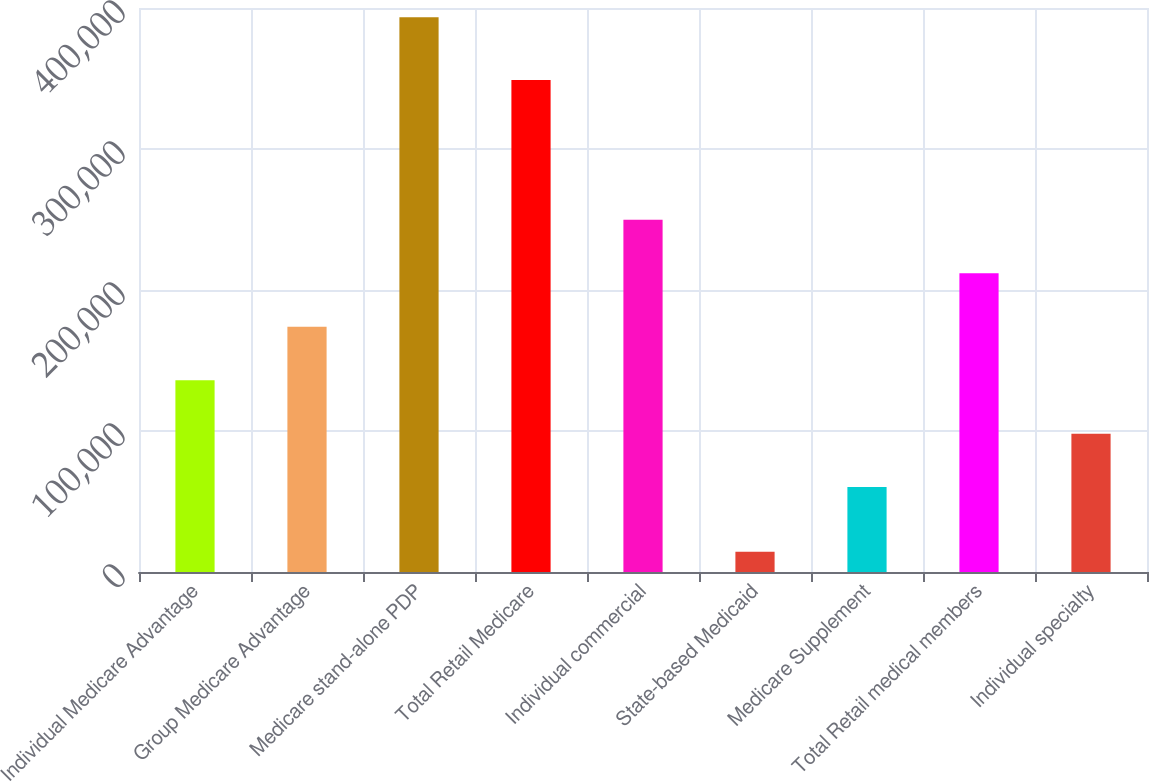<chart> <loc_0><loc_0><loc_500><loc_500><bar_chart><fcel>Individual Medicare Advantage<fcel>Group Medicare Advantage<fcel>Medicare stand-alone PDP<fcel>Total Retail Medicare<fcel>Individual commercial<fcel>State-based Medicaid<fcel>Medicare Supplement<fcel>Total Retail medical members<fcel>Individual specialty<nl><fcel>136020<fcel>173930<fcel>393500<fcel>349000<fcel>249750<fcel>14400<fcel>60200<fcel>211840<fcel>98110<nl></chart> 